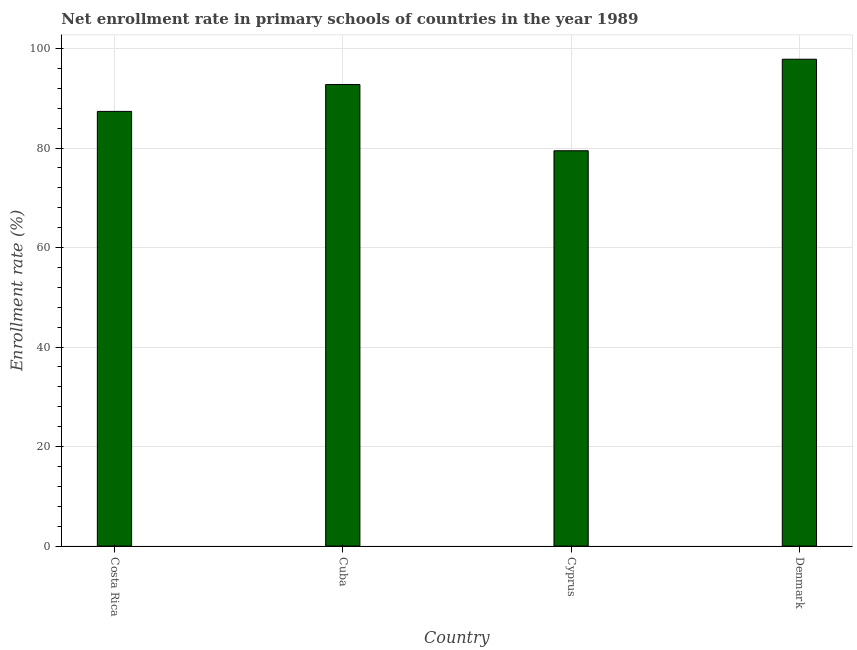Does the graph contain any zero values?
Provide a succinct answer. No. What is the title of the graph?
Your answer should be compact. Net enrollment rate in primary schools of countries in the year 1989. What is the label or title of the X-axis?
Your answer should be compact. Country. What is the label or title of the Y-axis?
Offer a terse response. Enrollment rate (%). What is the net enrollment rate in primary schools in Costa Rica?
Keep it short and to the point. 87.37. Across all countries, what is the maximum net enrollment rate in primary schools?
Offer a terse response. 97.86. Across all countries, what is the minimum net enrollment rate in primary schools?
Give a very brief answer. 79.46. In which country was the net enrollment rate in primary schools minimum?
Give a very brief answer. Cyprus. What is the sum of the net enrollment rate in primary schools?
Keep it short and to the point. 357.46. What is the difference between the net enrollment rate in primary schools in Cuba and Cyprus?
Keep it short and to the point. 13.32. What is the average net enrollment rate in primary schools per country?
Your response must be concise. 89.36. What is the median net enrollment rate in primary schools?
Provide a succinct answer. 90.07. What is the ratio of the net enrollment rate in primary schools in Cyprus to that in Denmark?
Ensure brevity in your answer.  0.81. Is the net enrollment rate in primary schools in Cuba less than that in Cyprus?
Your response must be concise. No. Is the difference between the net enrollment rate in primary schools in Cuba and Cyprus greater than the difference between any two countries?
Give a very brief answer. No. What is the difference between the highest and the second highest net enrollment rate in primary schools?
Make the answer very short. 5.08. How many countries are there in the graph?
Offer a very short reply. 4. Are the values on the major ticks of Y-axis written in scientific E-notation?
Your answer should be compact. No. What is the Enrollment rate (%) in Costa Rica?
Your answer should be very brief. 87.37. What is the Enrollment rate (%) of Cuba?
Offer a terse response. 92.78. What is the Enrollment rate (%) in Cyprus?
Provide a succinct answer. 79.46. What is the Enrollment rate (%) in Denmark?
Your answer should be very brief. 97.86. What is the difference between the Enrollment rate (%) in Costa Rica and Cuba?
Your answer should be very brief. -5.41. What is the difference between the Enrollment rate (%) in Costa Rica and Cyprus?
Your response must be concise. 7.91. What is the difference between the Enrollment rate (%) in Costa Rica and Denmark?
Your answer should be compact. -10.49. What is the difference between the Enrollment rate (%) in Cuba and Cyprus?
Keep it short and to the point. 13.32. What is the difference between the Enrollment rate (%) in Cuba and Denmark?
Your answer should be very brief. -5.08. What is the difference between the Enrollment rate (%) in Cyprus and Denmark?
Provide a short and direct response. -18.4. What is the ratio of the Enrollment rate (%) in Costa Rica to that in Cuba?
Provide a short and direct response. 0.94. What is the ratio of the Enrollment rate (%) in Costa Rica to that in Denmark?
Ensure brevity in your answer.  0.89. What is the ratio of the Enrollment rate (%) in Cuba to that in Cyprus?
Give a very brief answer. 1.17. What is the ratio of the Enrollment rate (%) in Cuba to that in Denmark?
Your answer should be compact. 0.95. What is the ratio of the Enrollment rate (%) in Cyprus to that in Denmark?
Offer a terse response. 0.81. 